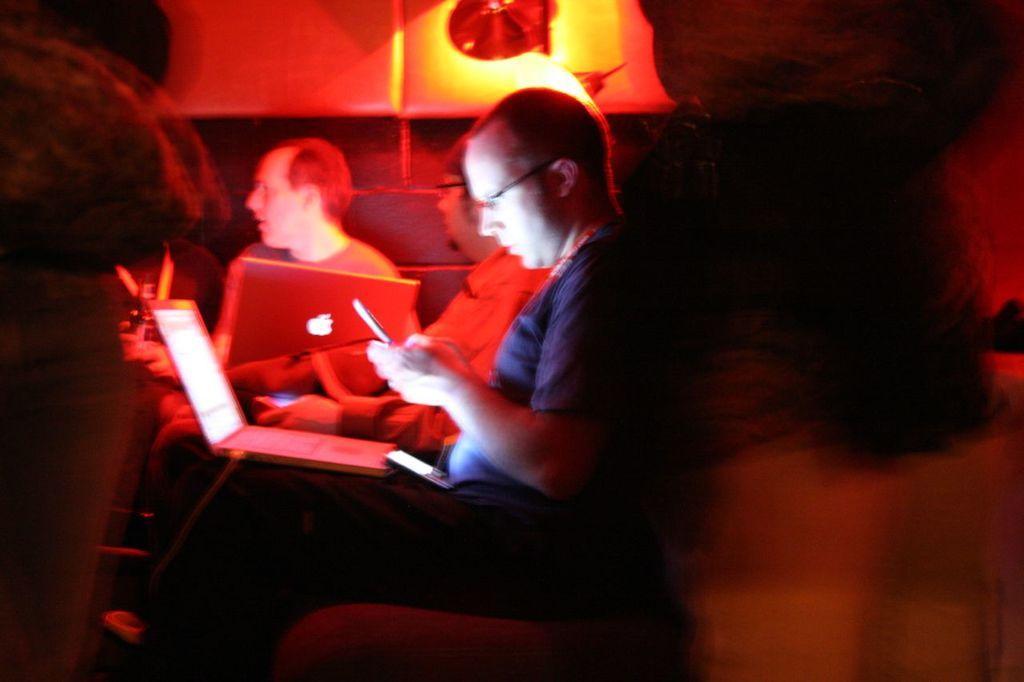How would you summarize this image in a sentence or two? In this image we can see person sitting on the sofa and holding laptops on their laps. 